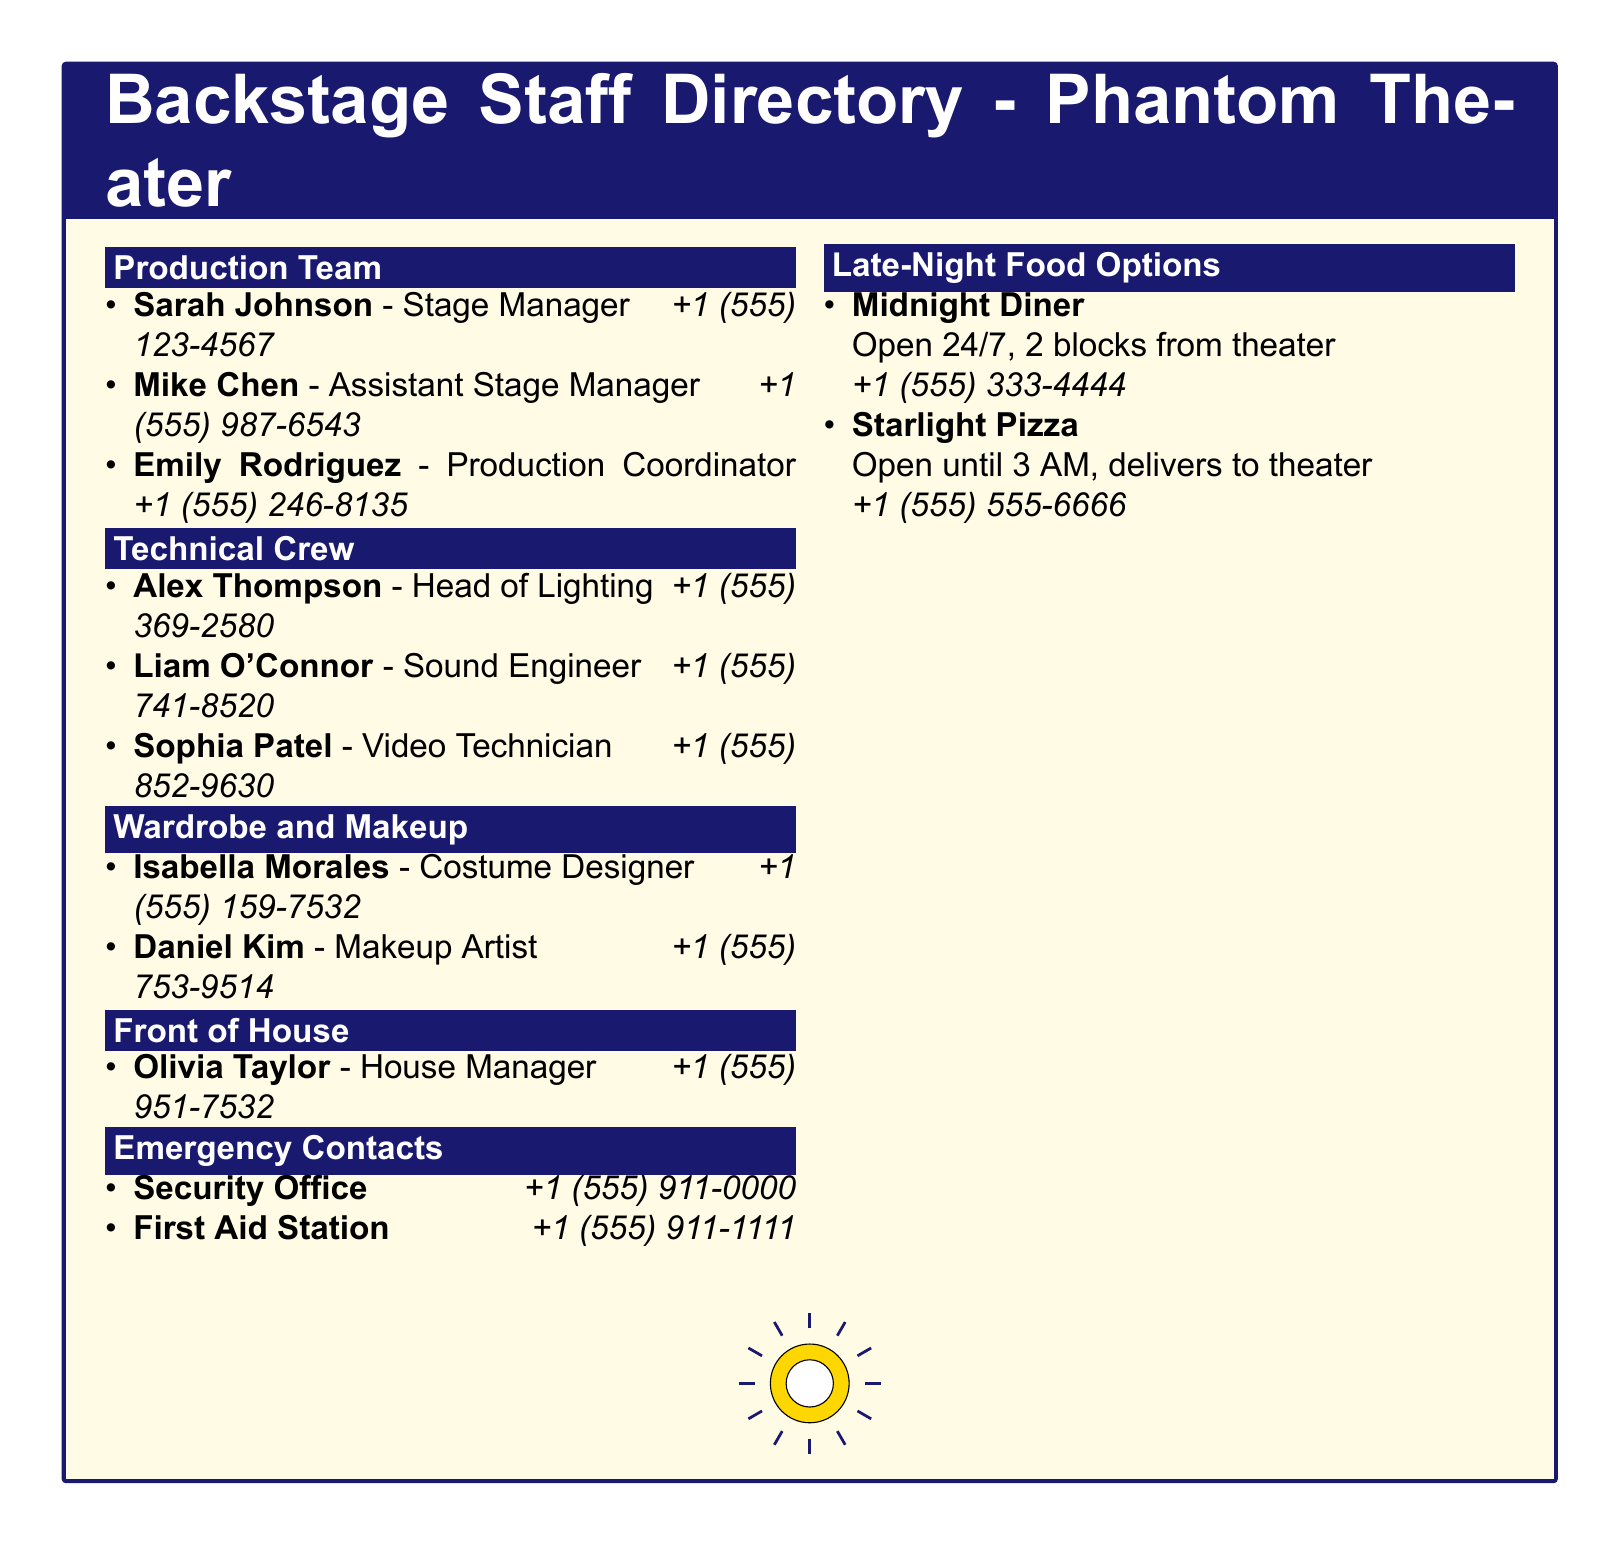What is the name of the Stage Manager? The Stage Manager's name is specifically listed under the Production Team in the document.
Answer: Sarah Johnson What is Mike Chen's role? Mike Chen's role is detailed within the Production Team section of the document.
Answer: Assistant Stage Manager What is the contact number for the Sound Engineer? The contact number for the Sound Engineer can be found in the Technical Crew section.
Answer: +1 (555) 741-8520 Which emergency contact is available for First Aid? The First Aid contact information is provided in the Emergency Contacts section of the document.
Answer: +1 (555) 911-1111 Where can you find food options open late at night? Late-night food options are specifically highlighted towards the end of the document.
Answer: Late-Night Food Options What is the name of the Head of Lighting? The name of the Head of Lighting is mentioned in the Technical Crew section.
Answer: Alex Thompson How many people are listed in the Wardrobe and Makeup section? The number of people in the Wardrobe and Makeup section can be counted directly from that section in the document.
Answer: 2 What time does Starlight Pizza close? The closing time for Starlight Pizza is explicitly stated in the Late-Night Food Options section.
Answer: 3 AM What is the title of the document? The title of the document is clearly indicated at the beginning of the tcolorbox.
Answer: Backstage Staff Directory - Phantom Theater 